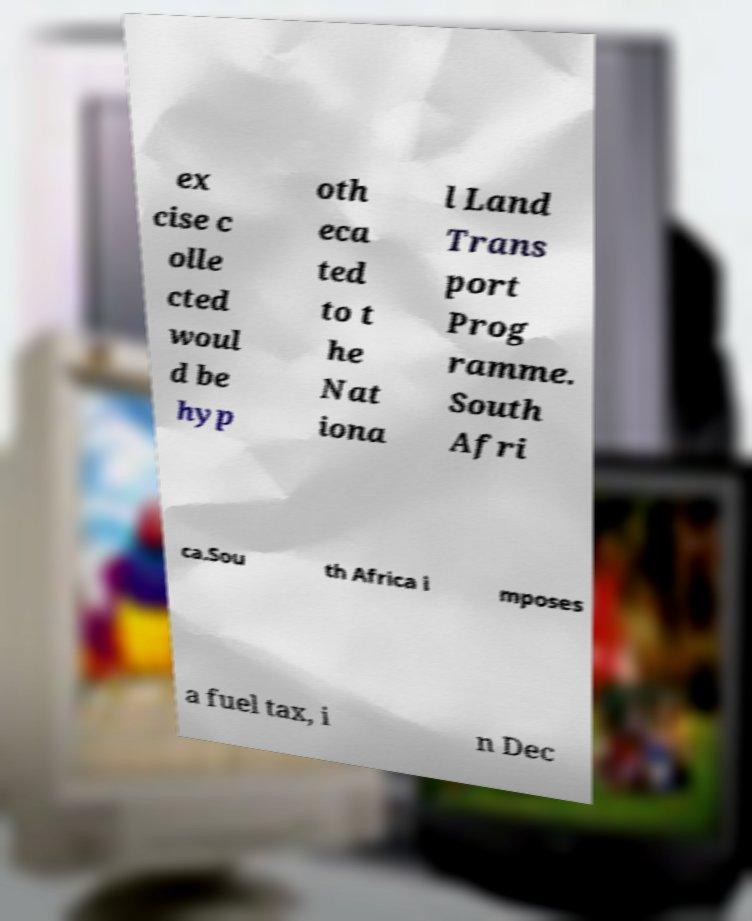Can you accurately transcribe the text from the provided image for me? ex cise c olle cted woul d be hyp oth eca ted to t he Nat iona l Land Trans port Prog ramme. South Afri ca.Sou th Africa i mposes a fuel tax, i n Dec 